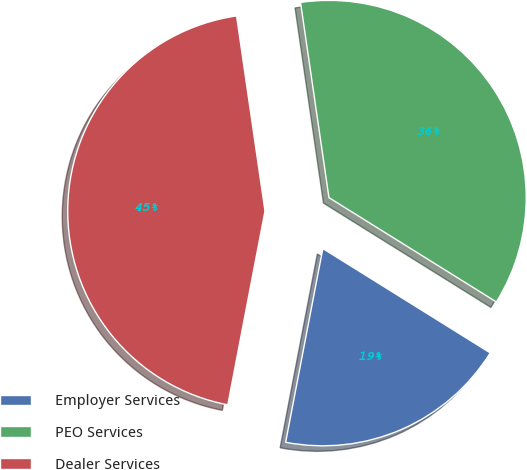Convert chart to OTSL. <chart><loc_0><loc_0><loc_500><loc_500><pie_chart><fcel>Employer Services<fcel>PEO Services<fcel>Dealer Services<nl><fcel>19.15%<fcel>36.17%<fcel>44.68%<nl></chart> 